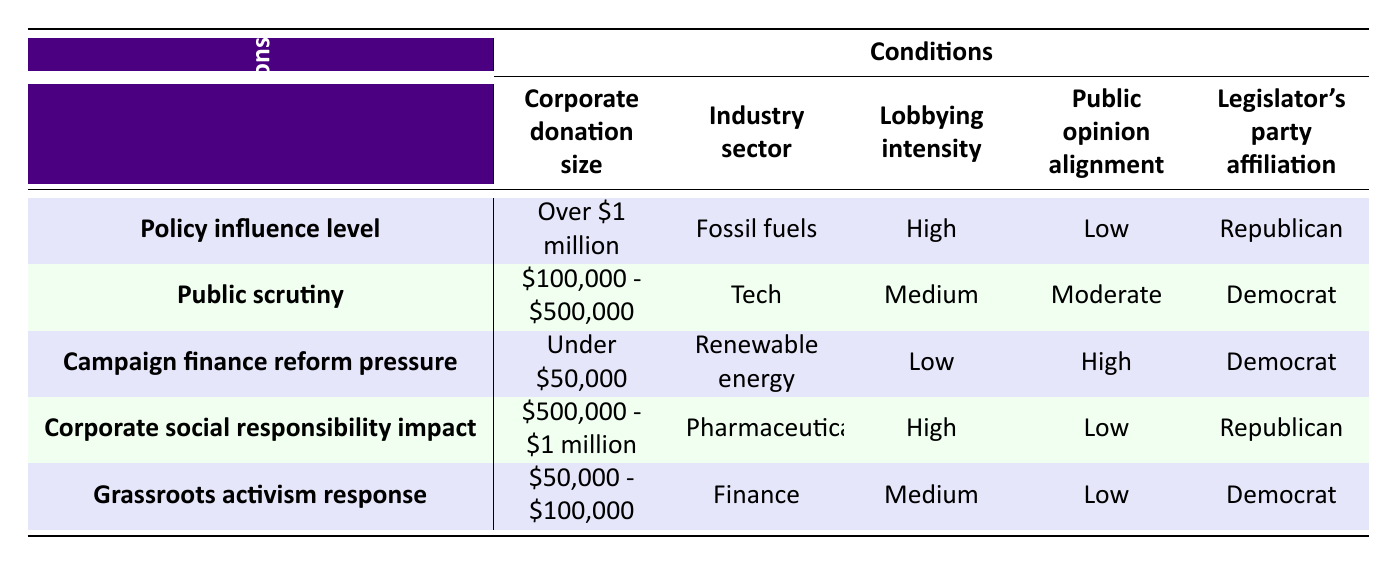What is the policy influence level for donations over $1 million from the fossil fuels sector? The table shows that for the condition of corporate donation size "Over $1 million" and industry sector "Fossil fuels," the policy influence level is "Significant."
Answer: Significant Which industry sector aligns with public opinion for donations under $50,000? Referring to the row that mentions "Under $50,000," the industry sector that has high public opinion alignment is "Renewable energy."
Answer: Renewable energy Is there a case where the campaign finance reform pressure is strong? Yes, from the table, both the "$500,000 - $1 million" (Pharmaceuticals) and "$50,000 - $100,000" (Finance) donation sizes have a campaign finance reform pressure listed as "Strong."
Answer: Yes What is the impact on corporate social responsibility for the pharmaceutical sector with donations between $500,000 and $1 million? The table specifies that for the corporate donation size of "$500,000 - $1 million" and industry sector "Pharmaceuticals," the corporate social responsibility impact is "Negative."
Answer: Negative For legislators affiliated with the Democratic party, what is the relationship between corporate donation size and public scrutiny? According to the table, both donation sizes of "$100,000 - $500,000" (Tech) and "$50,000 - $100,000" (Finance) show medium public scrutiny levels, while the donation of "Under $50,000" (Renewable energy) shows low public scrutiny. The pattern suggests that as the donation size increases within this range, public scrutiny may vary but is not directly correlated to higher scrutiny in these cases.
Answer: Varies What levels of grassroots activism response occur for donations in the range of $500,000 to $1 million? The table indicates that for the donation size of "$500,000 - $1 million" (Pharmaceuticals), the grassroots activism response is "Protests." Since there are no other cases defined for this donation range, the response is specific to this segment.
Answer: Protests 